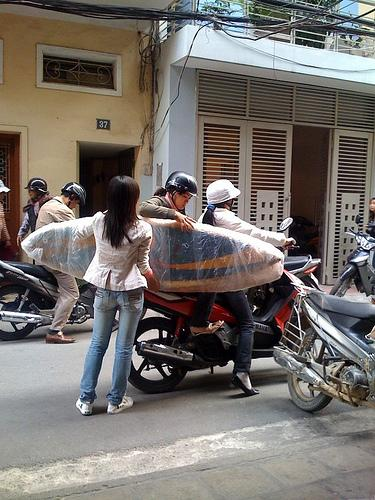What is the cellophane wrapping applied over top of?

Choices:
A) helmet
B) surfboard
C) bike
D) package surfboard 